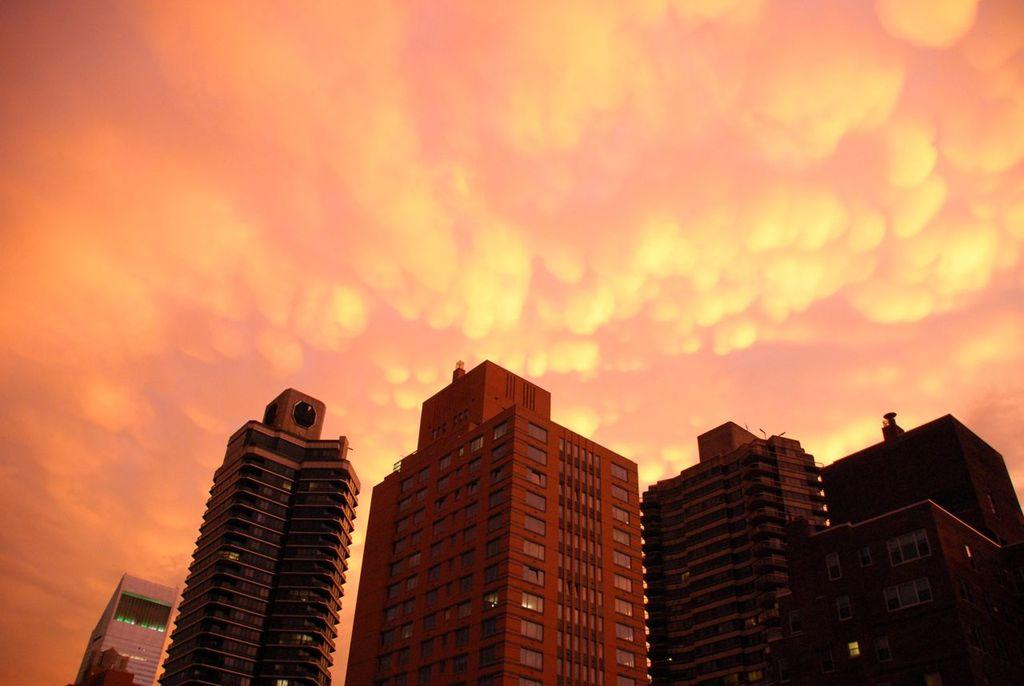What structures can be seen in the image? There are buildings in the image. What part of the natural environment is visible in the image? The sky is visible in the background of the image. What type of beam can be seen supporting the home in the image? There is no home or beam present in the image; it only features buildings and the sky. 